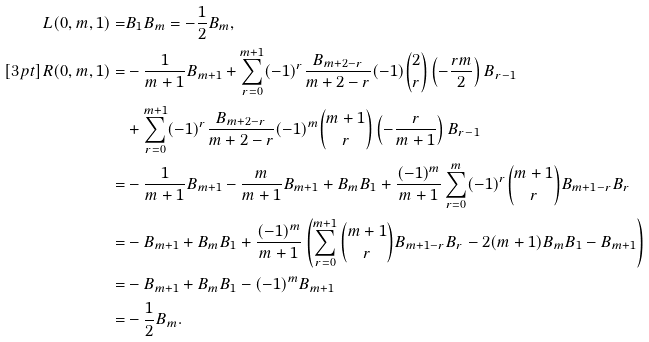<formula> <loc_0><loc_0><loc_500><loc_500>L ( 0 , m , 1 ) = & B _ { 1 } B _ { m } = - \frac { 1 } { 2 } B _ { m } , \\ [ 3 p t ] R ( 0 , m , 1 ) = & - \frac { 1 } { m + 1 } B _ { m + 1 } + \sum _ { r = 0 } ^ { m + 1 } ( - 1 ) ^ { r } \frac { B _ { m + 2 - r } } { m + 2 - r } ( - 1 ) { 2 \choose r } \left ( - \frac { r m } { 2 } \right ) B _ { r - 1 } \\ & + \sum _ { r = 0 } ^ { m + 1 } ( - 1 ) ^ { r } \frac { B _ { m + 2 - r } } { m + 2 - r } ( - 1 ) ^ { m } { m + 1 \choose r } \left ( - \frac { r } { m + 1 } \right ) B _ { r - 1 } \\ = & - \frac { 1 } { m + 1 } B _ { m + 1 } - \frac { m } { m + 1 } B _ { m + 1 } + B _ { m } B _ { 1 } + \frac { ( - 1 ) ^ { m } } { m + 1 } \sum _ { r = 0 } ^ { m } ( - 1 ) ^ { r } { m + 1 \choose r } B _ { m + 1 - r } B _ { r } \\ = & - B _ { m + 1 } + B _ { m } B _ { 1 } + \frac { ( - 1 ) ^ { m } } { m + 1 } \left ( \sum _ { r = 0 } ^ { m + 1 } { m + 1 \choose r } B _ { m + 1 - r } B _ { r } - 2 ( m + 1 ) B _ { m } B _ { 1 } - B _ { m + 1 } \right ) \\ = & - B _ { m + 1 } + B _ { m } B _ { 1 } - ( - 1 ) ^ { m } B _ { m + 1 } \\ = & - \frac { 1 } { 2 } B _ { m } .</formula> 